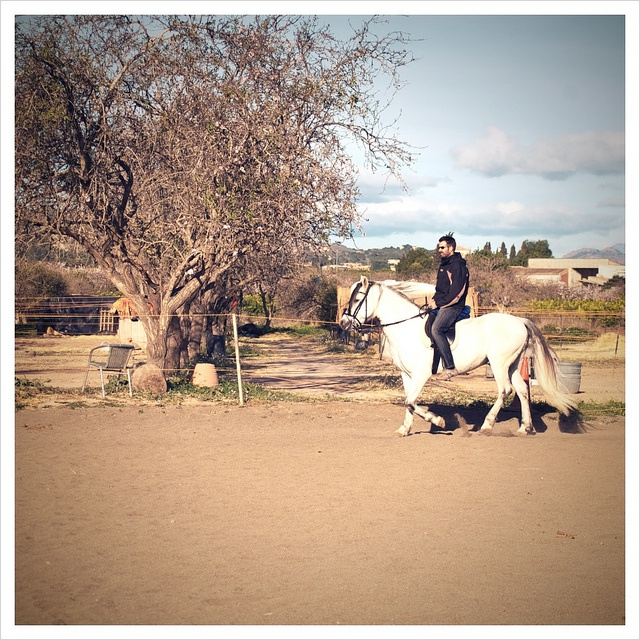Describe the objects in this image and their specific colors. I can see horse in lightgray, ivory, tan, and gray tones, people in lightgray, black, gray, and tan tones, and chair in lightgray, gray, and tan tones in this image. 